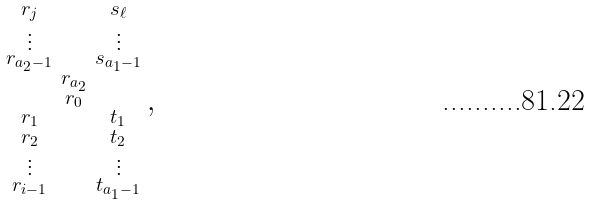Convert formula to latex. <formula><loc_0><loc_0><loc_500><loc_500>\begin{smallmatrix} r _ { j } & & s _ { \ell } \\ \vdots & & \vdots \\ r _ { a _ { 2 } - 1 } & & s _ { a _ { 1 } - 1 } \\ & r _ { a _ { 2 } } & \\ & r _ { 0 } & \\ r _ { 1 } & & t _ { 1 } \\ r _ { 2 } & & t _ { 2 } \\ \vdots & & \vdots \\ r _ { i - 1 } & & t _ { a _ { 1 } - 1 } \end{smallmatrix} ,</formula> 